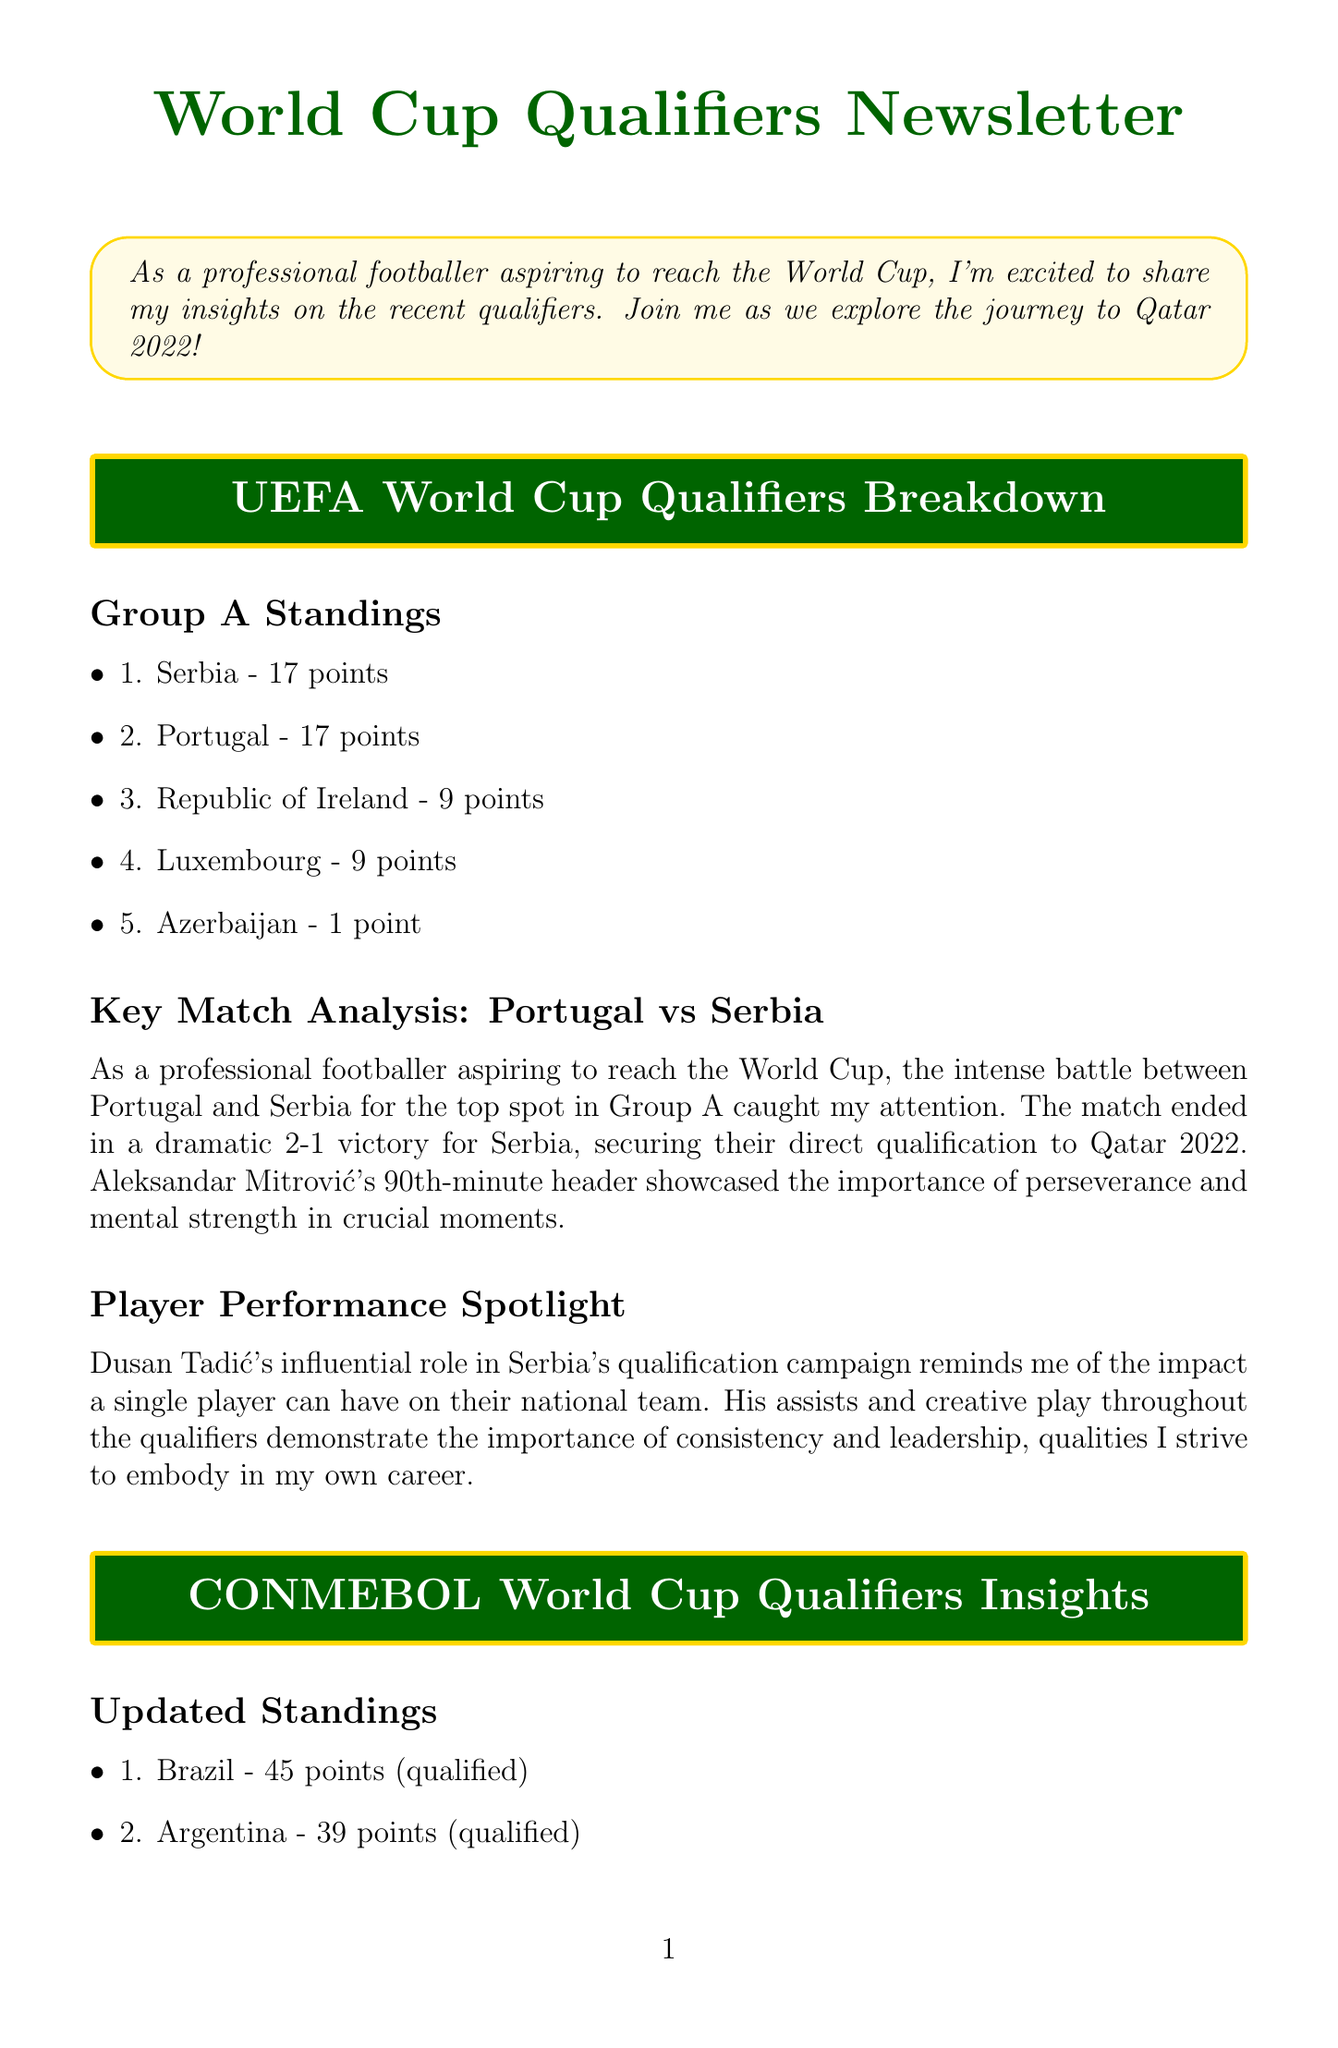what are the top two teams in Group A? Group A standings show the top two teams are Serbia and Portugal, both with 17 points.
Answer: Serbia and Portugal who scored the winning goal for Serbia against Portugal? The match analysis indicates that Aleksandar Mitrović scored the winning goal in the 90th minute.
Answer: Aleksandar Mitrović how many points does Ecuador have in the CONMEBOL standings? The updated standings indicate that Ecuador has 25 points.
Answer: 25 points which player had significant influence in Serbia's qualification campaign? The player performance spotlight highlights Dusan Tadić's influential role in Serbia's campaign.
Answer: Dusan Tadić what was the final score in the Japan vs Australia match? The key match section reveals that Japan won the match 2-1.
Answer: 2-1 how many points does Saudi Arabia have in Group B? The Group B standings indicate that Saudi Arabia has 23 points.
Answer: 23 points who is the rising star mentioned in the CONMEBOL section? The document mentions Julián Álvarez as the rising star from Argentina.
Answer: Julián Álvarez what lesson does the document infer from Brazil vs Argentina match? The match analysis emphasizes the need for players to be focused and prepared for unexpected situations.
Answer: Focus and preparation what highlights the importance of perseverance in the newsletter? The dramatic late goal by Mitrović in the Portugal vs Serbia match illustrates the significance of perseverance.
Answer: Mitrović's goal 